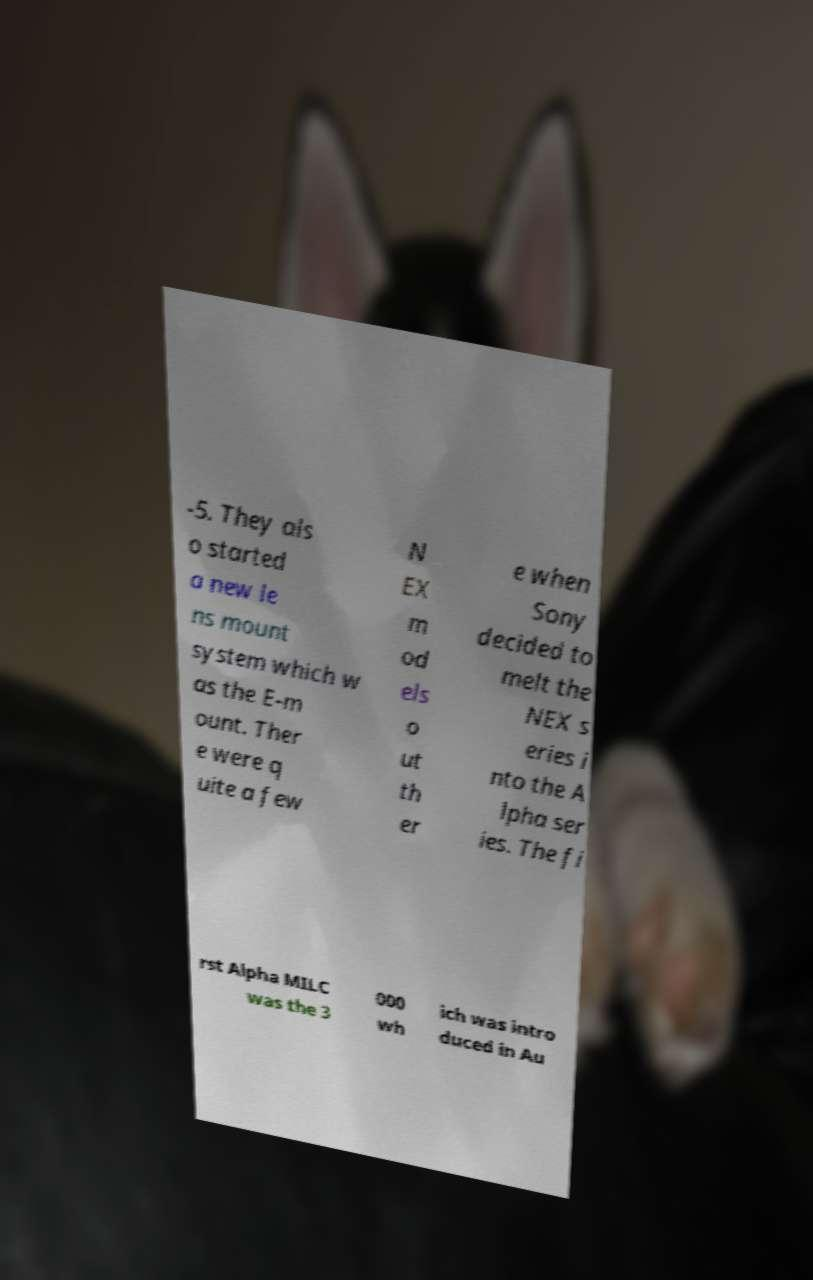Could you extract and type out the text from this image? -5. They als o started a new le ns mount system which w as the E-m ount. Ther e were q uite a few N EX m od els o ut th er e when Sony decided to melt the NEX s eries i nto the A lpha ser ies. The fi rst Alpha MILC was the 3 000 wh ich was intro duced in Au 